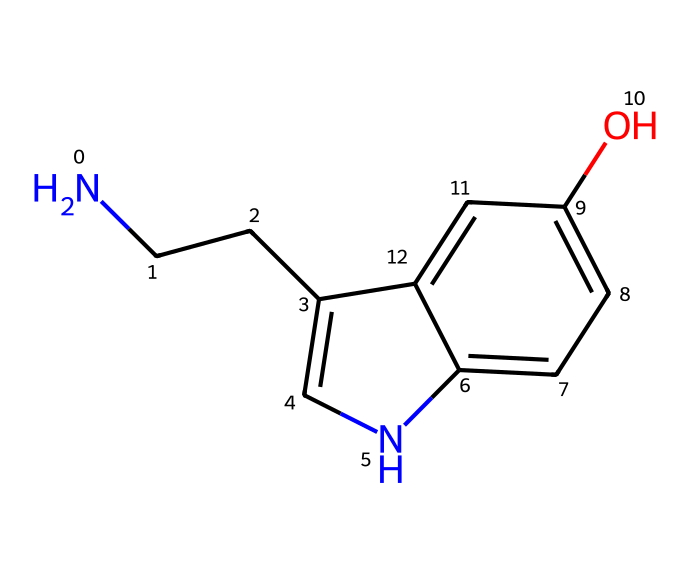What is the chemical name of this structure? The SMILES representation corresponds to serotonin, which is a well-known neurotransmitter. The presence of both the indole ring and the amine group indicates its identification as serotonin.
Answer: serotonin How many carbon atoms are in this chemical? By analyzing the SMILES, we count the carbon (C) atoms, which include those in the ring structures and side chains. There are a total of 10 carbon atoms present in the structure.
Answer: 10 Which functional group is present in this structure? Observing the structure, we identify a hydroxyl (-OH) group attached to one of the benzene rings. This functional group is characteristic of phenolic compounds.
Answer: hydroxyl group What is the total number of nitrogen atoms present? Looking at the SMILES, we find one nitrogen (N) atom in the side chain and one in the indole ring, totaling to two nitrogen atoms in this structure.
Answer: 2 Is this chemical polar or nonpolar? The presence of multiple polar functional groups, such as the amine and hydroxyl groups, suggests the molecule has a net polar character due to the ability of these groups to form hydrogen bonds.
Answer: polar What role does serotonin primarily play in the body? Serotonin primarily acts as a neurotransmitter that helps regulate mood and emotional states, influencing feelings of well-being and happiness.
Answer: mood regulation How many rings are present in the structure? Examining the structure, we find that there are two fused ring systems, characteristic of indole, and this contributes to the overall complexity of the serotonin molecule.
Answer: 2 